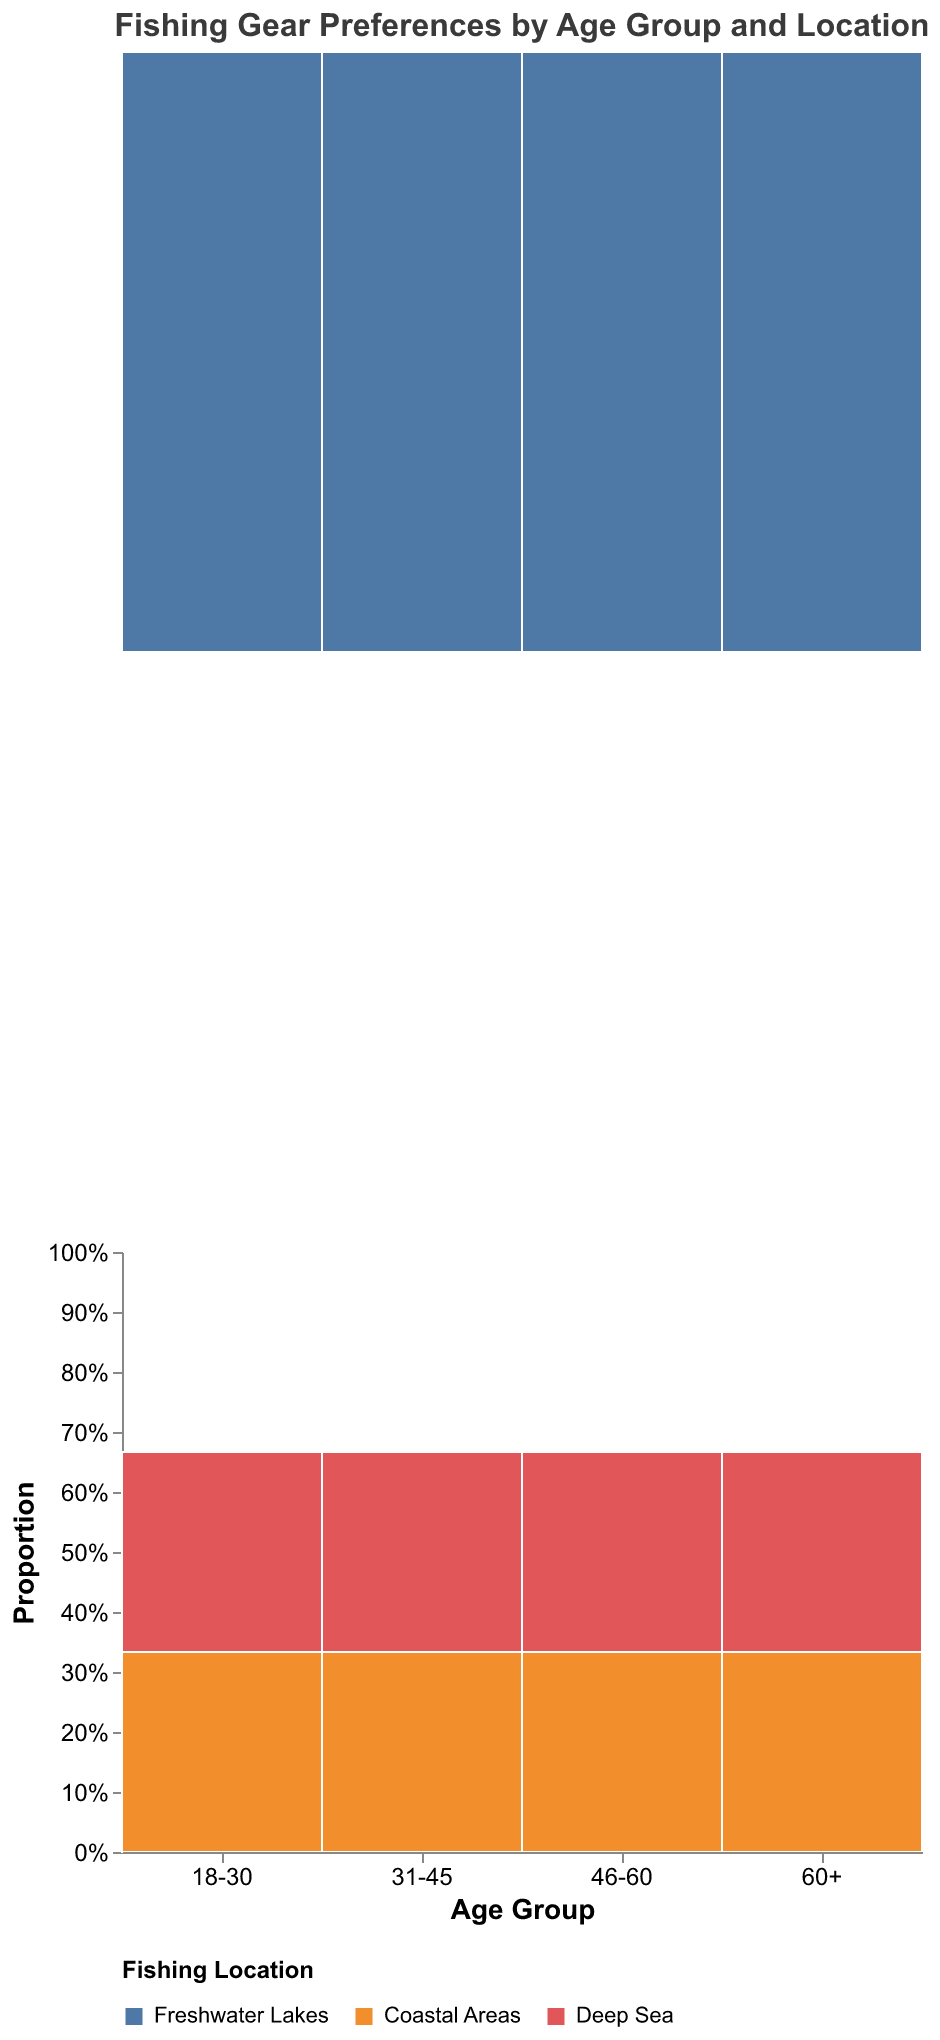What is the title of the plot? The title of the plot is displayed at the top of the figure. It reads "Fishing Gear Preferences by Age Group and Location".
Answer: Fishing Gear Preferences by Age Group and Location What are the age groups represented in the plot? The x-axis of the plot displays the age groups, which are "18-30", "31-45", "46-60", and "60+".
Answer: 18-30, 31-45, 46-60, 60+ Which fishing location has the highest proportion within the "31-45" age group? Look at the "31-45" age group bar and identify the section with the highest height in the stack. The section for "Coastal Areas" is the tallest.
Answer: Coastal Areas What fishing gear is preferred by the "60+" age group in freshwater lakes? Each segment’s tooltip provides details; hover over the segment corresponding to "60+" and "Freshwater Lakes" to see that "Telescopic Rods" are preferred.
Answer: Telescopic Rods How does the preference for fly fishing rods differ between the age groups? Observe the segments representing fly fishing rods for each age group. Only the "31-45" and "46-60" age groups have segments for fly fishing rods, so these age groups prefer this gear.
Answer: "31-45" and "46-60" What is the proportion difference between the "Deep Sea" and "Freshwater Lakes" locations for the "46-60" age group? Calculate the proportion heights of the segments for "Deep Sea" and "Freshwater Lakes" within the "46-60" group, and find the difference. The "Deep Sea" proportion is higher.
Answer: Deep Sea > Freshwater Lakes Which age group shows the most variety in preferred gear? Count the different segments within each age group. The age group "31-45" shows the most variety as it has diversified preferences among different gears.
Answer: 31-45 Which location has the lowest proportion within the "18-30" age group? Look at the smallest segment in the "18-30" category. The segment for "Deep Sea" is the smallest, indicating the lowest proportion.
Answer: Deep Sea How many different fishing locations are represented in the plot? The legend at the bottom of the figure shows the unique colors for each fishing location, which are three in total: "Freshwater Lakes", "Coastal Areas", and "Deep Sea".
Answer: 3 What fishing gear is preferred in coastal areas by the "60+" age group? Hover over the segment corresponding to "60+" and "Coastal Areas" to find that "Spinning Reels" are preferred.
Answer: Spinning Reels 